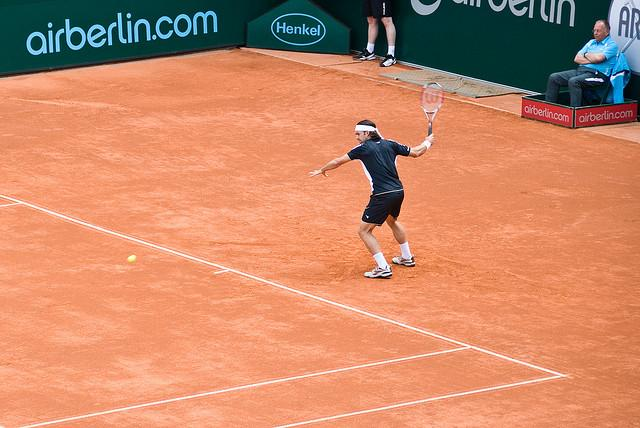In which country is the city mentioned here located? Please explain your reasoning. germany. Berlin is in germany. 